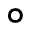<formula> <loc_0><loc_0><loc_500><loc_500>\circ</formula> 